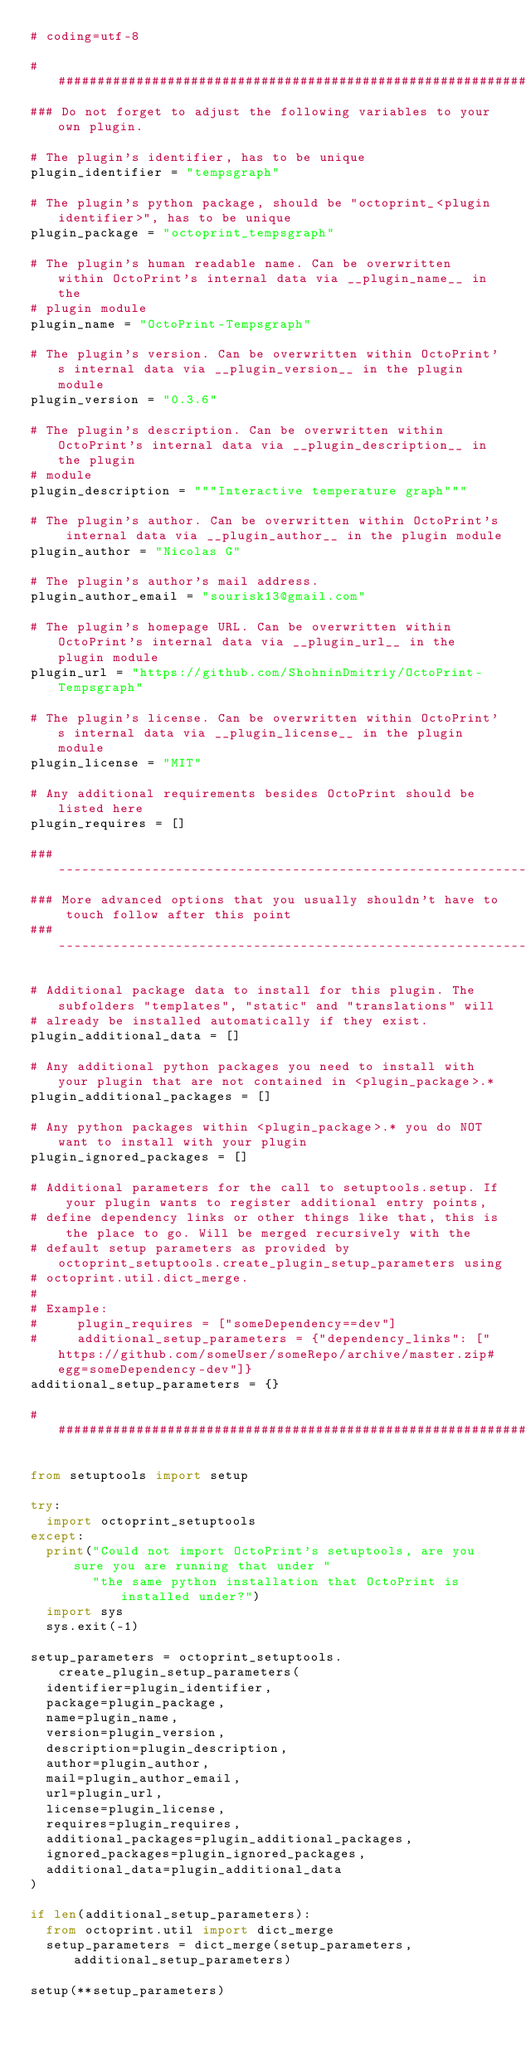Convert code to text. <code><loc_0><loc_0><loc_500><loc_500><_Python_># coding=utf-8

########################################################################################################################
### Do not forget to adjust the following variables to your own plugin.

# The plugin's identifier, has to be unique
plugin_identifier = "tempsgraph"

# The plugin's python package, should be "octoprint_<plugin identifier>", has to be unique
plugin_package = "octoprint_tempsgraph"

# The plugin's human readable name. Can be overwritten within OctoPrint's internal data via __plugin_name__ in the
# plugin module
plugin_name = "OctoPrint-Tempsgraph"

# The plugin's version. Can be overwritten within OctoPrint's internal data via __plugin_version__ in the plugin module
plugin_version = "0.3.6"

# The plugin's description. Can be overwritten within OctoPrint's internal data via __plugin_description__ in the plugin
# module
plugin_description = """Interactive temperature graph"""

# The plugin's author. Can be overwritten within OctoPrint's internal data via __plugin_author__ in the plugin module
plugin_author = "Nicolas G"

# The plugin's author's mail address.
plugin_author_email = "sourisk13@gmail.com"

# The plugin's homepage URL. Can be overwritten within OctoPrint's internal data via __plugin_url__ in the plugin module
plugin_url = "https://github.com/ShohninDmitriy/OctoPrint-Tempsgraph"

# The plugin's license. Can be overwritten within OctoPrint's internal data via __plugin_license__ in the plugin module
plugin_license = "MIT"

# Any additional requirements besides OctoPrint should be listed here
plugin_requires = []

### --------------------------------------------------------------------------------------------------------------------
### More advanced options that you usually shouldn't have to touch follow after this point
### --------------------------------------------------------------------------------------------------------------------

# Additional package data to install for this plugin. The subfolders "templates", "static" and "translations" will
# already be installed automatically if they exist.
plugin_additional_data = []

# Any additional python packages you need to install with your plugin that are not contained in <plugin_package>.*
plugin_additional_packages = []

# Any python packages within <plugin_package>.* you do NOT want to install with your plugin
plugin_ignored_packages = []

# Additional parameters for the call to setuptools.setup. If your plugin wants to register additional entry points,
# define dependency links or other things like that, this is the place to go. Will be merged recursively with the
# default setup parameters as provided by octoprint_setuptools.create_plugin_setup_parameters using
# octoprint.util.dict_merge.
#
# Example:
#     plugin_requires = ["someDependency==dev"]
#     additional_setup_parameters = {"dependency_links": ["https://github.com/someUser/someRepo/archive/master.zip#egg=someDependency-dev"]}
additional_setup_parameters = {}

########################################################################################################################

from setuptools import setup

try:
	import octoprint_setuptools
except:
	print("Could not import OctoPrint's setuptools, are you sure you are running that under "
	      "the same python installation that OctoPrint is installed under?")
	import sys
	sys.exit(-1)

setup_parameters = octoprint_setuptools.create_plugin_setup_parameters(
	identifier=plugin_identifier,
	package=plugin_package,
	name=plugin_name,
	version=plugin_version,
	description=plugin_description,
	author=plugin_author,
	mail=plugin_author_email,
	url=plugin_url,
	license=plugin_license,
	requires=plugin_requires,
	additional_packages=plugin_additional_packages,
	ignored_packages=plugin_ignored_packages,
	additional_data=plugin_additional_data
)

if len(additional_setup_parameters):
	from octoprint.util import dict_merge
	setup_parameters = dict_merge(setup_parameters, additional_setup_parameters)

setup(**setup_parameters)
</code> 